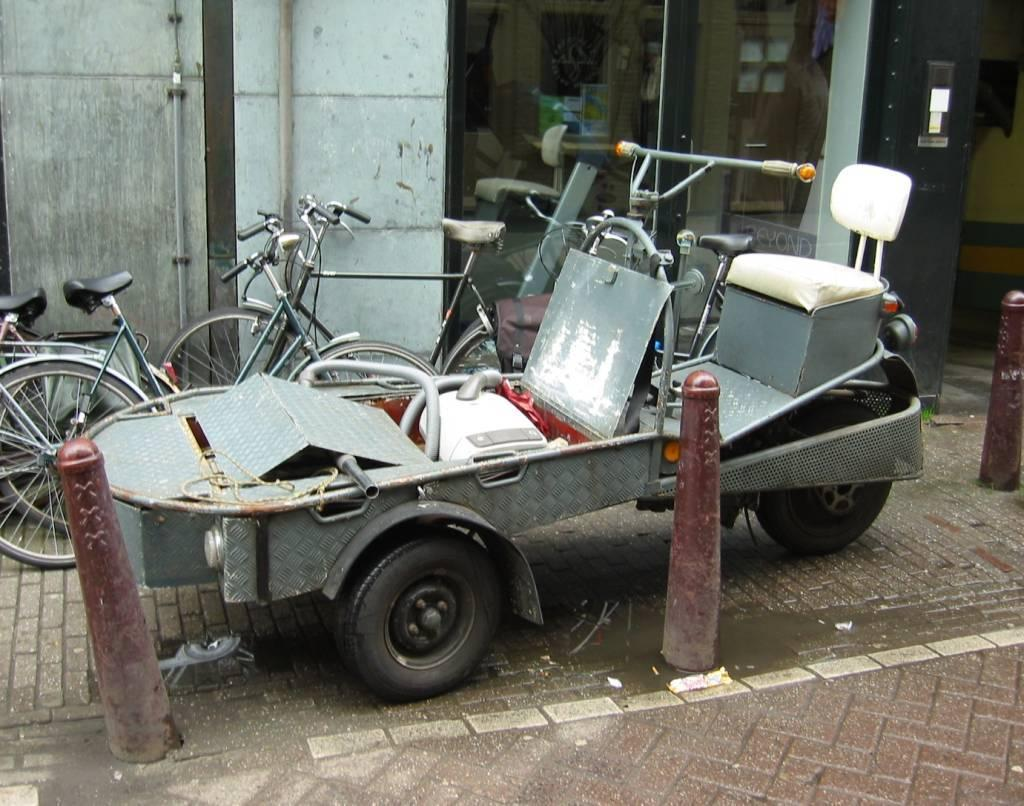What type of vehicle is in the image? There is a motorcycle in the image. Are there any other vehicles in the image? Yes, there are bicycles in the image. Where are the motorcycle and bicycles located? The motorcycle and bicycles are on the road in the image. What else can be seen in the image besides the vehicles? There is a wall and pipes in the image. What type of card is being sold at the market in the image? There is no market or card present in the image; it features a motorcycle, bicycles, a wall, and pipes. 